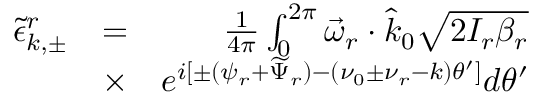<formula> <loc_0><loc_0><loc_500><loc_500>\begin{array} { r l r } { \tilde { \epsilon } _ { k , \pm } ^ { r } } & { = } & { \frac { 1 } { 4 \pi } \int _ { 0 } ^ { 2 \pi } \vec { \omega } _ { r } \cdot \hat { k } _ { 0 } \sqrt { 2 I _ { r } \beta _ { r } } } \\ & { \times } & { e ^ { i [ \pm ( \psi _ { r } + \widetilde { \Psi } _ { r } ) - ( \nu _ { 0 } \pm \nu _ { r } - k ) \theta ^ { \prime } ] } d \theta ^ { \prime } } \end{array}</formula> 